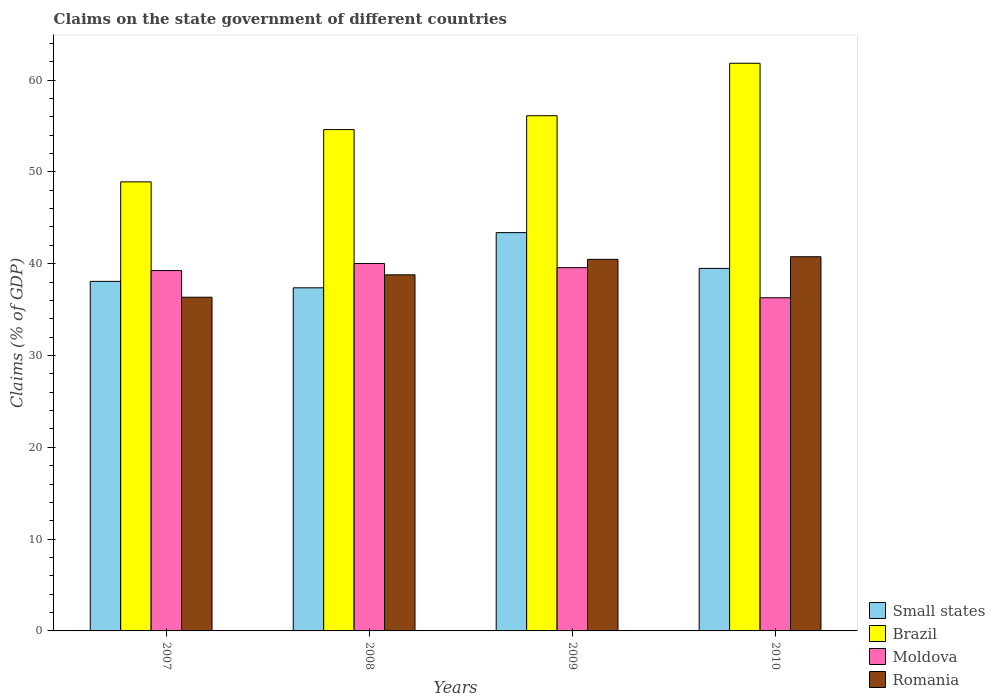How many groups of bars are there?
Keep it short and to the point. 4. Are the number of bars on each tick of the X-axis equal?
Your answer should be very brief. Yes. How many bars are there on the 3rd tick from the left?
Provide a succinct answer. 4. What is the percentage of GDP claimed on the state government in Brazil in 2010?
Give a very brief answer. 61.83. Across all years, what is the maximum percentage of GDP claimed on the state government in Small states?
Your answer should be very brief. 43.38. Across all years, what is the minimum percentage of GDP claimed on the state government in Moldova?
Provide a short and direct response. 36.29. In which year was the percentage of GDP claimed on the state government in Moldova maximum?
Ensure brevity in your answer.  2008. What is the total percentage of GDP claimed on the state government in Brazil in the graph?
Your response must be concise. 221.47. What is the difference between the percentage of GDP claimed on the state government in Romania in 2007 and that in 2008?
Provide a succinct answer. -2.44. What is the difference between the percentage of GDP claimed on the state government in Moldova in 2008 and the percentage of GDP claimed on the state government in Brazil in 2009?
Offer a very short reply. -16.1. What is the average percentage of GDP claimed on the state government in Moldova per year?
Provide a succinct answer. 38.78. In the year 2008, what is the difference between the percentage of GDP claimed on the state government in Small states and percentage of GDP claimed on the state government in Brazil?
Give a very brief answer. -17.23. What is the ratio of the percentage of GDP claimed on the state government in Romania in 2009 to that in 2010?
Make the answer very short. 0.99. Is the difference between the percentage of GDP claimed on the state government in Small states in 2007 and 2008 greater than the difference between the percentage of GDP claimed on the state government in Brazil in 2007 and 2008?
Provide a short and direct response. Yes. What is the difference between the highest and the second highest percentage of GDP claimed on the state government in Brazil?
Your response must be concise. 5.71. What is the difference between the highest and the lowest percentage of GDP claimed on the state government in Moldova?
Make the answer very short. 3.73. What does the 3rd bar from the left in 2007 represents?
Provide a short and direct response. Moldova. Is it the case that in every year, the sum of the percentage of GDP claimed on the state government in Small states and percentage of GDP claimed on the state government in Brazil is greater than the percentage of GDP claimed on the state government in Moldova?
Offer a terse response. Yes. What is the difference between two consecutive major ticks on the Y-axis?
Give a very brief answer. 10. Are the values on the major ticks of Y-axis written in scientific E-notation?
Your response must be concise. No. Does the graph contain any zero values?
Provide a succinct answer. No. Does the graph contain grids?
Your answer should be compact. No. Where does the legend appear in the graph?
Offer a very short reply. Bottom right. How many legend labels are there?
Offer a very short reply. 4. What is the title of the graph?
Your response must be concise. Claims on the state government of different countries. Does "Vanuatu" appear as one of the legend labels in the graph?
Your answer should be very brief. No. What is the label or title of the Y-axis?
Give a very brief answer. Claims (% of GDP). What is the Claims (% of GDP) in Small states in 2007?
Provide a succinct answer. 38.07. What is the Claims (% of GDP) in Brazil in 2007?
Ensure brevity in your answer.  48.91. What is the Claims (% of GDP) in Moldova in 2007?
Provide a short and direct response. 39.25. What is the Claims (% of GDP) of Romania in 2007?
Your answer should be compact. 36.35. What is the Claims (% of GDP) of Small states in 2008?
Your response must be concise. 37.37. What is the Claims (% of GDP) in Brazil in 2008?
Your answer should be very brief. 54.61. What is the Claims (% of GDP) in Moldova in 2008?
Ensure brevity in your answer.  40.02. What is the Claims (% of GDP) of Romania in 2008?
Offer a very short reply. 38.78. What is the Claims (% of GDP) in Small states in 2009?
Provide a short and direct response. 43.38. What is the Claims (% of GDP) in Brazil in 2009?
Keep it short and to the point. 56.12. What is the Claims (% of GDP) of Moldova in 2009?
Keep it short and to the point. 39.57. What is the Claims (% of GDP) in Romania in 2009?
Make the answer very short. 40.47. What is the Claims (% of GDP) in Small states in 2010?
Keep it short and to the point. 39.49. What is the Claims (% of GDP) of Brazil in 2010?
Provide a short and direct response. 61.83. What is the Claims (% of GDP) in Moldova in 2010?
Keep it short and to the point. 36.29. What is the Claims (% of GDP) in Romania in 2010?
Your answer should be compact. 40.76. Across all years, what is the maximum Claims (% of GDP) in Small states?
Your answer should be compact. 43.38. Across all years, what is the maximum Claims (% of GDP) in Brazil?
Provide a short and direct response. 61.83. Across all years, what is the maximum Claims (% of GDP) in Moldova?
Your response must be concise. 40.02. Across all years, what is the maximum Claims (% of GDP) in Romania?
Your answer should be compact. 40.76. Across all years, what is the minimum Claims (% of GDP) in Small states?
Provide a succinct answer. 37.37. Across all years, what is the minimum Claims (% of GDP) in Brazil?
Make the answer very short. 48.91. Across all years, what is the minimum Claims (% of GDP) in Moldova?
Your answer should be compact. 36.29. Across all years, what is the minimum Claims (% of GDP) of Romania?
Your answer should be compact. 36.35. What is the total Claims (% of GDP) in Small states in the graph?
Keep it short and to the point. 158.32. What is the total Claims (% of GDP) in Brazil in the graph?
Your answer should be compact. 221.47. What is the total Claims (% of GDP) in Moldova in the graph?
Offer a very short reply. 155.12. What is the total Claims (% of GDP) in Romania in the graph?
Offer a terse response. 156.36. What is the difference between the Claims (% of GDP) of Small states in 2007 and that in 2008?
Make the answer very short. 0.7. What is the difference between the Claims (% of GDP) of Brazil in 2007 and that in 2008?
Your answer should be very brief. -5.69. What is the difference between the Claims (% of GDP) of Moldova in 2007 and that in 2008?
Your response must be concise. -0.77. What is the difference between the Claims (% of GDP) of Romania in 2007 and that in 2008?
Your answer should be compact. -2.44. What is the difference between the Claims (% of GDP) of Small states in 2007 and that in 2009?
Make the answer very short. -5.31. What is the difference between the Claims (% of GDP) in Brazil in 2007 and that in 2009?
Keep it short and to the point. -7.2. What is the difference between the Claims (% of GDP) of Moldova in 2007 and that in 2009?
Keep it short and to the point. -0.32. What is the difference between the Claims (% of GDP) of Romania in 2007 and that in 2009?
Your answer should be compact. -4.12. What is the difference between the Claims (% of GDP) of Small states in 2007 and that in 2010?
Offer a terse response. -1.41. What is the difference between the Claims (% of GDP) in Brazil in 2007 and that in 2010?
Make the answer very short. -12.92. What is the difference between the Claims (% of GDP) of Moldova in 2007 and that in 2010?
Ensure brevity in your answer.  2.96. What is the difference between the Claims (% of GDP) of Romania in 2007 and that in 2010?
Your answer should be very brief. -4.41. What is the difference between the Claims (% of GDP) of Small states in 2008 and that in 2009?
Keep it short and to the point. -6.01. What is the difference between the Claims (% of GDP) of Brazil in 2008 and that in 2009?
Your response must be concise. -1.51. What is the difference between the Claims (% of GDP) in Moldova in 2008 and that in 2009?
Give a very brief answer. 0.45. What is the difference between the Claims (% of GDP) in Romania in 2008 and that in 2009?
Keep it short and to the point. -1.69. What is the difference between the Claims (% of GDP) in Small states in 2008 and that in 2010?
Your answer should be very brief. -2.12. What is the difference between the Claims (% of GDP) in Brazil in 2008 and that in 2010?
Provide a succinct answer. -7.23. What is the difference between the Claims (% of GDP) in Moldova in 2008 and that in 2010?
Provide a succinct answer. 3.73. What is the difference between the Claims (% of GDP) in Romania in 2008 and that in 2010?
Your answer should be very brief. -1.97. What is the difference between the Claims (% of GDP) in Small states in 2009 and that in 2010?
Your response must be concise. 3.9. What is the difference between the Claims (% of GDP) in Brazil in 2009 and that in 2010?
Provide a succinct answer. -5.71. What is the difference between the Claims (% of GDP) of Moldova in 2009 and that in 2010?
Provide a succinct answer. 3.28. What is the difference between the Claims (% of GDP) of Romania in 2009 and that in 2010?
Your response must be concise. -0.28. What is the difference between the Claims (% of GDP) of Small states in 2007 and the Claims (% of GDP) of Brazil in 2008?
Your answer should be compact. -16.53. What is the difference between the Claims (% of GDP) of Small states in 2007 and the Claims (% of GDP) of Moldova in 2008?
Provide a short and direct response. -1.94. What is the difference between the Claims (% of GDP) of Small states in 2007 and the Claims (% of GDP) of Romania in 2008?
Your answer should be compact. -0.71. What is the difference between the Claims (% of GDP) in Brazil in 2007 and the Claims (% of GDP) in Moldova in 2008?
Ensure brevity in your answer.  8.9. What is the difference between the Claims (% of GDP) of Brazil in 2007 and the Claims (% of GDP) of Romania in 2008?
Offer a very short reply. 10.13. What is the difference between the Claims (% of GDP) in Moldova in 2007 and the Claims (% of GDP) in Romania in 2008?
Offer a very short reply. 0.46. What is the difference between the Claims (% of GDP) in Small states in 2007 and the Claims (% of GDP) in Brazil in 2009?
Provide a succinct answer. -18.04. What is the difference between the Claims (% of GDP) in Small states in 2007 and the Claims (% of GDP) in Moldova in 2009?
Give a very brief answer. -1.49. What is the difference between the Claims (% of GDP) in Small states in 2007 and the Claims (% of GDP) in Romania in 2009?
Offer a terse response. -2.4. What is the difference between the Claims (% of GDP) in Brazil in 2007 and the Claims (% of GDP) in Moldova in 2009?
Keep it short and to the point. 9.34. What is the difference between the Claims (% of GDP) in Brazil in 2007 and the Claims (% of GDP) in Romania in 2009?
Keep it short and to the point. 8.44. What is the difference between the Claims (% of GDP) of Moldova in 2007 and the Claims (% of GDP) of Romania in 2009?
Your answer should be very brief. -1.22. What is the difference between the Claims (% of GDP) of Small states in 2007 and the Claims (% of GDP) of Brazil in 2010?
Make the answer very short. -23.76. What is the difference between the Claims (% of GDP) of Small states in 2007 and the Claims (% of GDP) of Moldova in 2010?
Provide a short and direct response. 1.79. What is the difference between the Claims (% of GDP) in Small states in 2007 and the Claims (% of GDP) in Romania in 2010?
Your answer should be very brief. -2.68. What is the difference between the Claims (% of GDP) of Brazil in 2007 and the Claims (% of GDP) of Moldova in 2010?
Offer a very short reply. 12.63. What is the difference between the Claims (% of GDP) of Brazil in 2007 and the Claims (% of GDP) of Romania in 2010?
Give a very brief answer. 8.16. What is the difference between the Claims (% of GDP) of Moldova in 2007 and the Claims (% of GDP) of Romania in 2010?
Provide a succinct answer. -1.51. What is the difference between the Claims (% of GDP) of Small states in 2008 and the Claims (% of GDP) of Brazil in 2009?
Your answer should be compact. -18.74. What is the difference between the Claims (% of GDP) of Small states in 2008 and the Claims (% of GDP) of Moldova in 2009?
Make the answer very short. -2.2. What is the difference between the Claims (% of GDP) in Small states in 2008 and the Claims (% of GDP) in Romania in 2009?
Offer a very short reply. -3.1. What is the difference between the Claims (% of GDP) in Brazil in 2008 and the Claims (% of GDP) in Moldova in 2009?
Make the answer very short. 15.04. What is the difference between the Claims (% of GDP) of Brazil in 2008 and the Claims (% of GDP) of Romania in 2009?
Your answer should be compact. 14.13. What is the difference between the Claims (% of GDP) of Moldova in 2008 and the Claims (% of GDP) of Romania in 2009?
Your response must be concise. -0.46. What is the difference between the Claims (% of GDP) in Small states in 2008 and the Claims (% of GDP) in Brazil in 2010?
Ensure brevity in your answer.  -24.46. What is the difference between the Claims (% of GDP) of Small states in 2008 and the Claims (% of GDP) of Moldova in 2010?
Give a very brief answer. 1.09. What is the difference between the Claims (% of GDP) in Small states in 2008 and the Claims (% of GDP) in Romania in 2010?
Make the answer very short. -3.38. What is the difference between the Claims (% of GDP) of Brazil in 2008 and the Claims (% of GDP) of Moldova in 2010?
Your answer should be very brief. 18.32. What is the difference between the Claims (% of GDP) of Brazil in 2008 and the Claims (% of GDP) of Romania in 2010?
Provide a succinct answer. 13.85. What is the difference between the Claims (% of GDP) of Moldova in 2008 and the Claims (% of GDP) of Romania in 2010?
Your answer should be very brief. -0.74. What is the difference between the Claims (% of GDP) of Small states in 2009 and the Claims (% of GDP) of Brazil in 2010?
Give a very brief answer. -18.45. What is the difference between the Claims (% of GDP) of Small states in 2009 and the Claims (% of GDP) of Moldova in 2010?
Your answer should be very brief. 7.1. What is the difference between the Claims (% of GDP) of Small states in 2009 and the Claims (% of GDP) of Romania in 2010?
Give a very brief answer. 2.63. What is the difference between the Claims (% of GDP) in Brazil in 2009 and the Claims (% of GDP) in Moldova in 2010?
Your answer should be very brief. 19.83. What is the difference between the Claims (% of GDP) of Brazil in 2009 and the Claims (% of GDP) of Romania in 2010?
Give a very brief answer. 15.36. What is the difference between the Claims (% of GDP) in Moldova in 2009 and the Claims (% of GDP) in Romania in 2010?
Make the answer very short. -1.19. What is the average Claims (% of GDP) in Small states per year?
Keep it short and to the point. 39.58. What is the average Claims (% of GDP) of Brazil per year?
Make the answer very short. 55.37. What is the average Claims (% of GDP) in Moldova per year?
Provide a short and direct response. 38.78. What is the average Claims (% of GDP) of Romania per year?
Your response must be concise. 39.09. In the year 2007, what is the difference between the Claims (% of GDP) of Small states and Claims (% of GDP) of Brazil?
Your answer should be compact. -10.84. In the year 2007, what is the difference between the Claims (% of GDP) of Small states and Claims (% of GDP) of Moldova?
Your response must be concise. -1.17. In the year 2007, what is the difference between the Claims (% of GDP) of Small states and Claims (% of GDP) of Romania?
Keep it short and to the point. 1.73. In the year 2007, what is the difference between the Claims (% of GDP) of Brazil and Claims (% of GDP) of Moldova?
Provide a short and direct response. 9.66. In the year 2007, what is the difference between the Claims (% of GDP) of Brazil and Claims (% of GDP) of Romania?
Your answer should be compact. 12.57. In the year 2007, what is the difference between the Claims (% of GDP) of Moldova and Claims (% of GDP) of Romania?
Give a very brief answer. 2.9. In the year 2008, what is the difference between the Claims (% of GDP) in Small states and Claims (% of GDP) in Brazil?
Give a very brief answer. -17.23. In the year 2008, what is the difference between the Claims (% of GDP) in Small states and Claims (% of GDP) in Moldova?
Keep it short and to the point. -2.64. In the year 2008, what is the difference between the Claims (% of GDP) in Small states and Claims (% of GDP) in Romania?
Ensure brevity in your answer.  -1.41. In the year 2008, what is the difference between the Claims (% of GDP) in Brazil and Claims (% of GDP) in Moldova?
Provide a succinct answer. 14.59. In the year 2008, what is the difference between the Claims (% of GDP) in Brazil and Claims (% of GDP) in Romania?
Give a very brief answer. 15.82. In the year 2008, what is the difference between the Claims (% of GDP) of Moldova and Claims (% of GDP) of Romania?
Your response must be concise. 1.23. In the year 2009, what is the difference between the Claims (% of GDP) in Small states and Claims (% of GDP) in Brazil?
Your answer should be compact. -12.73. In the year 2009, what is the difference between the Claims (% of GDP) in Small states and Claims (% of GDP) in Moldova?
Keep it short and to the point. 3.82. In the year 2009, what is the difference between the Claims (% of GDP) in Small states and Claims (% of GDP) in Romania?
Make the answer very short. 2.91. In the year 2009, what is the difference between the Claims (% of GDP) of Brazil and Claims (% of GDP) of Moldova?
Your answer should be very brief. 16.55. In the year 2009, what is the difference between the Claims (% of GDP) in Brazil and Claims (% of GDP) in Romania?
Make the answer very short. 15.65. In the year 2009, what is the difference between the Claims (% of GDP) in Moldova and Claims (% of GDP) in Romania?
Offer a terse response. -0.9. In the year 2010, what is the difference between the Claims (% of GDP) of Small states and Claims (% of GDP) of Brazil?
Your answer should be compact. -22.34. In the year 2010, what is the difference between the Claims (% of GDP) in Small states and Claims (% of GDP) in Moldova?
Give a very brief answer. 3.2. In the year 2010, what is the difference between the Claims (% of GDP) in Small states and Claims (% of GDP) in Romania?
Give a very brief answer. -1.27. In the year 2010, what is the difference between the Claims (% of GDP) in Brazil and Claims (% of GDP) in Moldova?
Your response must be concise. 25.54. In the year 2010, what is the difference between the Claims (% of GDP) of Brazil and Claims (% of GDP) of Romania?
Offer a very short reply. 21.07. In the year 2010, what is the difference between the Claims (% of GDP) of Moldova and Claims (% of GDP) of Romania?
Your response must be concise. -4.47. What is the ratio of the Claims (% of GDP) in Small states in 2007 to that in 2008?
Keep it short and to the point. 1.02. What is the ratio of the Claims (% of GDP) in Brazil in 2007 to that in 2008?
Your answer should be compact. 0.9. What is the ratio of the Claims (% of GDP) of Moldova in 2007 to that in 2008?
Your response must be concise. 0.98. What is the ratio of the Claims (% of GDP) of Romania in 2007 to that in 2008?
Your answer should be very brief. 0.94. What is the ratio of the Claims (% of GDP) of Small states in 2007 to that in 2009?
Ensure brevity in your answer.  0.88. What is the ratio of the Claims (% of GDP) in Brazil in 2007 to that in 2009?
Make the answer very short. 0.87. What is the ratio of the Claims (% of GDP) of Moldova in 2007 to that in 2009?
Keep it short and to the point. 0.99. What is the ratio of the Claims (% of GDP) of Romania in 2007 to that in 2009?
Ensure brevity in your answer.  0.9. What is the ratio of the Claims (% of GDP) of Small states in 2007 to that in 2010?
Provide a short and direct response. 0.96. What is the ratio of the Claims (% of GDP) of Brazil in 2007 to that in 2010?
Offer a very short reply. 0.79. What is the ratio of the Claims (% of GDP) in Moldova in 2007 to that in 2010?
Offer a very short reply. 1.08. What is the ratio of the Claims (% of GDP) in Romania in 2007 to that in 2010?
Provide a succinct answer. 0.89. What is the ratio of the Claims (% of GDP) in Small states in 2008 to that in 2009?
Your answer should be very brief. 0.86. What is the ratio of the Claims (% of GDP) of Brazil in 2008 to that in 2009?
Ensure brevity in your answer.  0.97. What is the ratio of the Claims (% of GDP) in Moldova in 2008 to that in 2009?
Keep it short and to the point. 1.01. What is the ratio of the Claims (% of GDP) of Small states in 2008 to that in 2010?
Offer a very short reply. 0.95. What is the ratio of the Claims (% of GDP) in Brazil in 2008 to that in 2010?
Offer a terse response. 0.88. What is the ratio of the Claims (% of GDP) in Moldova in 2008 to that in 2010?
Keep it short and to the point. 1.1. What is the ratio of the Claims (% of GDP) of Romania in 2008 to that in 2010?
Offer a very short reply. 0.95. What is the ratio of the Claims (% of GDP) of Small states in 2009 to that in 2010?
Your response must be concise. 1.1. What is the ratio of the Claims (% of GDP) of Brazil in 2009 to that in 2010?
Offer a terse response. 0.91. What is the ratio of the Claims (% of GDP) of Moldova in 2009 to that in 2010?
Your response must be concise. 1.09. What is the difference between the highest and the second highest Claims (% of GDP) of Small states?
Ensure brevity in your answer.  3.9. What is the difference between the highest and the second highest Claims (% of GDP) in Brazil?
Your answer should be compact. 5.71. What is the difference between the highest and the second highest Claims (% of GDP) in Moldova?
Your answer should be very brief. 0.45. What is the difference between the highest and the second highest Claims (% of GDP) in Romania?
Provide a succinct answer. 0.28. What is the difference between the highest and the lowest Claims (% of GDP) in Small states?
Ensure brevity in your answer.  6.01. What is the difference between the highest and the lowest Claims (% of GDP) in Brazil?
Ensure brevity in your answer.  12.92. What is the difference between the highest and the lowest Claims (% of GDP) in Moldova?
Keep it short and to the point. 3.73. What is the difference between the highest and the lowest Claims (% of GDP) of Romania?
Give a very brief answer. 4.41. 